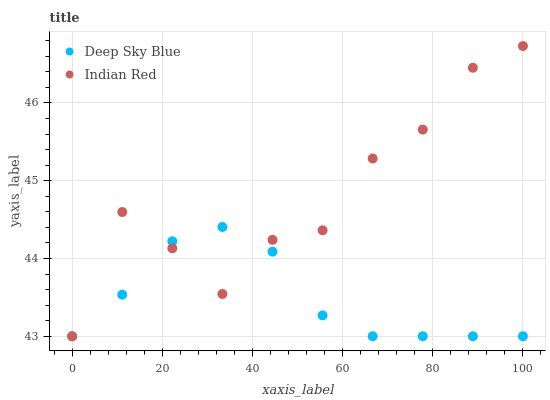Does Deep Sky Blue have the minimum area under the curve?
Answer yes or no. Yes. Does Indian Red have the maximum area under the curve?
Answer yes or no. Yes. Does Deep Sky Blue have the maximum area under the curve?
Answer yes or no. No. Is Deep Sky Blue the smoothest?
Answer yes or no. Yes. Is Indian Red the roughest?
Answer yes or no. Yes. Is Deep Sky Blue the roughest?
Answer yes or no. No. Does Indian Red have the lowest value?
Answer yes or no. Yes. Does Indian Red have the highest value?
Answer yes or no. Yes. Does Deep Sky Blue have the highest value?
Answer yes or no. No. Does Deep Sky Blue intersect Indian Red?
Answer yes or no. Yes. Is Deep Sky Blue less than Indian Red?
Answer yes or no. No. Is Deep Sky Blue greater than Indian Red?
Answer yes or no. No. 